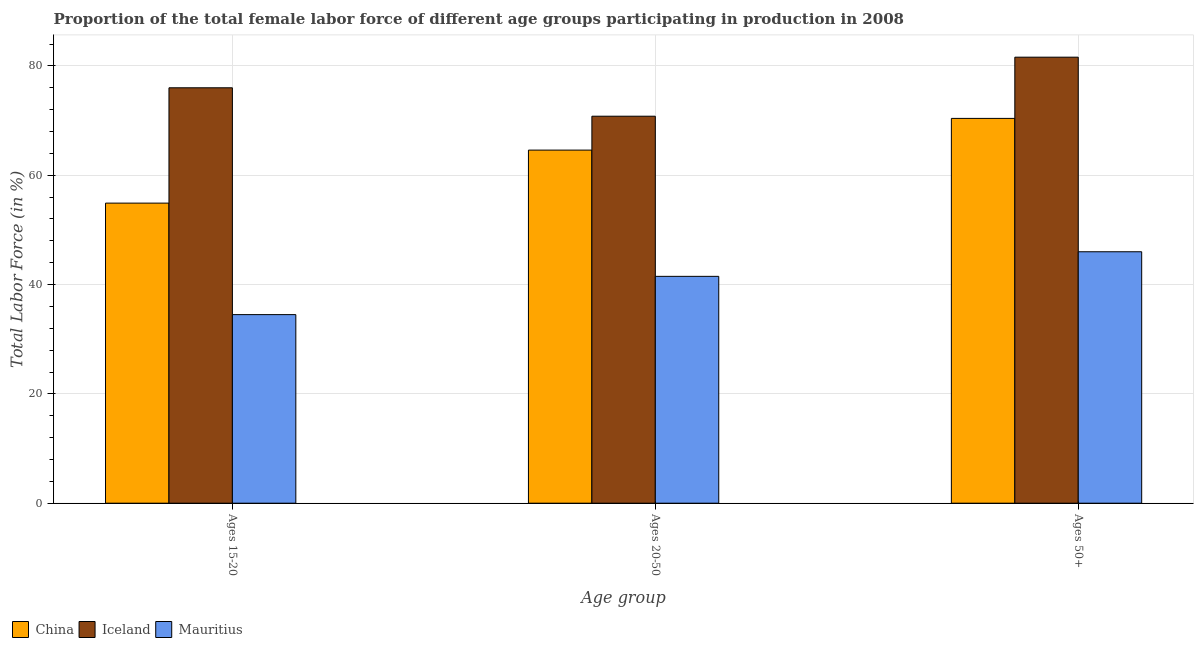How many different coloured bars are there?
Provide a succinct answer. 3. How many groups of bars are there?
Your answer should be compact. 3. Are the number of bars per tick equal to the number of legend labels?
Keep it short and to the point. Yes. Are the number of bars on each tick of the X-axis equal?
Give a very brief answer. Yes. How many bars are there on the 1st tick from the left?
Your response must be concise. 3. How many bars are there on the 3rd tick from the right?
Provide a short and direct response. 3. What is the label of the 1st group of bars from the left?
Your answer should be very brief. Ages 15-20. What is the percentage of female labor force within the age group 20-50 in Mauritius?
Make the answer very short. 41.5. Across all countries, what is the maximum percentage of female labor force within the age group 20-50?
Give a very brief answer. 70.8. Across all countries, what is the minimum percentage of female labor force within the age group 20-50?
Your answer should be compact. 41.5. In which country was the percentage of female labor force within the age group 20-50 minimum?
Your response must be concise. Mauritius. What is the total percentage of female labor force within the age group 20-50 in the graph?
Give a very brief answer. 176.9. What is the difference between the percentage of female labor force within the age group 15-20 in China and that in Iceland?
Make the answer very short. -21.1. What is the difference between the percentage of female labor force within the age group 20-50 in Iceland and the percentage of female labor force within the age group 15-20 in China?
Your answer should be compact. 15.9. What is the average percentage of female labor force above age 50 per country?
Provide a short and direct response. 66. What is the difference between the percentage of female labor force within the age group 15-20 and percentage of female labor force above age 50 in Iceland?
Make the answer very short. -5.6. What is the ratio of the percentage of female labor force within the age group 20-50 in China to that in Iceland?
Provide a succinct answer. 0.91. What is the difference between the highest and the second highest percentage of female labor force within the age group 15-20?
Your response must be concise. 21.1. What is the difference between the highest and the lowest percentage of female labor force above age 50?
Offer a terse response. 35.6. In how many countries, is the percentage of female labor force within the age group 20-50 greater than the average percentage of female labor force within the age group 20-50 taken over all countries?
Provide a succinct answer. 2. What does the 1st bar from the right in Ages 50+ represents?
Give a very brief answer. Mauritius. Are all the bars in the graph horizontal?
Offer a terse response. No. How many countries are there in the graph?
Your answer should be very brief. 3. Are the values on the major ticks of Y-axis written in scientific E-notation?
Provide a short and direct response. No. Does the graph contain any zero values?
Provide a succinct answer. No. Does the graph contain grids?
Your answer should be very brief. Yes. Where does the legend appear in the graph?
Offer a terse response. Bottom left. How are the legend labels stacked?
Your answer should be compact. Horizontal. What is the title of the graph?
Make the answer very short. Proportion of the total female labor force of different age groups participating in production in 2008. Does "American Samoa" appear as one of the legend labels in the graph?
Your answer should be very brief. No. What is the label or title of the X-axis?
Keep it short and to the point. Age group. What is the Total Labor Force (in %) of China in Ages 15-20?
Your response must be concise. 54.9. What is the Total Labor Force (in %) in Iceland in Ages 15-20?
Keep it short and to the point. 76. What is the Total Labor Force (in %) in Mauritius in Ages 15-20?
Keep it short and to the point. 34.5. What is the Total Labor Force (in %) of China in Ages 20-50?
Keep it short and to the point. 64.6. What is the Total Labor Force (in %) of Iceland in Ages 20-50?
Offer a very short reply. 70.8. What is the Total Labor Force (in %) of Mauritius in Ages 20-50?
Offer a terse response. 41.5. What is the Total Labor Force (in %) in China in Ages 50+?
Keep it short and to the point. 70.4. What is the Total Labor Force (in %) in Iceland in Ages 50+?
Your answer should be compact. 81.6. What is the Total Labor Force (in %) of Mauritius in Ages 50+?
Your answer should be very brief. 46. Across all Age group, what is the maximum Total Labor Force (in %) of China?
Your response must be concise. 70.4. Across all Age group, what is the maximum Total Labor Force (in %) of Iceland?
Provide a short and direct response. 81.6. Across all Age group, what is the maximum Total Labor Force (in %) in Mauritius?
Your answer should be compact. 46. Across all Age group, what is the minimum Total Labor Force (in %) of China?
Your answer should be very brief. 54.9. Across all Age group, what is the minimum Total Labor Force (in %) of Iceland?
Make the answer very short. 70.8. Across all Age group, what is the minimum Total Labor Force (in %) of Mauritius?
Your answer should be compact. 34.5. What is the total Total Labor Force (in %) in China in the graph?
Offer a terse response. 189.9. What is the total Total Labor Force (in %) of Iceland in the graph?
Ensure brevity in your answer.  228.4. What is the total Total Labor Force (in %) in Mauritius in the graph?
Offer a very short reply. 122. What is the difference between the Total Labor Force (in %) of Mauritius in Ages 15-20 and that in Ages 20-50?
Keep it short and to the point. -7. What is the difference between the Total Labor Force (in %) in China in Ages 15-20 and that in Ages 50+?
Offer a very short reply. -15.5. What is the difference between the Total Labor Force (in %) in Mauritius in Ages 20-50 and that in Ages 50+?
Your response must be concise. -4.5. What is the difference between the Total Labor Force (in %) of China in Ages 15-20 and the Total Labor Force (in %) of Iceland in Ages 20-50?
Your response must be concise. -15.9. What is the difference between the Total Labor Force (in %) of Iceland in Ages 15-20 and the Total Labor Force (in %) of Mauritius in Ages 20-50?
Keep it short and to the point. 34.5. What is the difference between the Total Labor Force (in %) of China in Ages 15-20 and the Total Labor Force (in %) of Iceland in Ages 50+?
Give a very brief answer. -26.7. What is the difference between the Total Labor Force (in %) of China in Ages 15-20 and the Total Labor Force (in %) of Mauritius in Ages 50+?
Make the answer very short. 8.9. What is the difference between the Total Labor Force (in %) in Iceland in Ages 20-50 and the Total Labor Force (in %) in Mauritius in Ages 50+?
Your answer should be compact. 24.8. What is the average Total Labor Force (in %) in China per Age group?
Your response must be concise. 63.3. What is the average Total Labor Force (in %) of Iceland per Age group?
Make the answer very short. 76.13. What is the average Total Labor Force (in %) of Mauritius per Age group?
Make the answer very short. 40.67. What is the difference between the Total Labor Force (in %) in China and Total Labor Force (in %) in Iceland in Ages 15-20?
Your answer should be compact. -21.1. What is the difference between the Total Labor Force (in %) of China and Total Labor Force (in %) of Mauritius in Ages 15-20?
Give a very brief answer. 20.4. What is the difference between the Total Labor Force (in %) in Iceland and Total Labor Force (in %) in Mauritius in Ages 15-20?
Ensure brevity in your answer.  41.5. What is the difference between the Total Labor Force (in %) of China and Total Labor Force (in %) of Iceland in Ages 20-50?
Ensure brevity in your answer.  -6.2. What is the difference between the Total Labor Force (in %) of China and Total Labor Force (in %) of Mauritius in Ages 20-50?
Offer a very short reply. 23.1. What is the difference between the Total Labor Force (in %) of Iceland and Total Labor Force (in %) of Mauritius in Ages 20-50?
Your response must be concise. 29.3. What is the difference between the Total Labor Force (in %) of China and Total Labor Force (in %) of Mauritius in Ages 50+?
Your response must be concise. 24.4. What is the difference between the Total Labor Force (in %) in Iceland and Total Labor Force (in %) in Mauritius in Ages 50+?
Provide a short and direct response. 35.6. What is the ratio of the Total Labor Force (in %) in China in Ages 15-20 to that in Ages 20-50?
Keep it short and to the point. 0.85. What is the ratio of the Total Labor Force (in %) of Iceland in Ages 15-20 to that in Ages 20-50?
Provide a short and direct response. 1.07. What is the ratio of the Total Labor Force (in %) of Mauritius in Ages 15-20 to that in Ages 20-50?
Provide a short and direct response. 0.83. What is the ratio of the Total Labor Force (in %) of China in Ages 15-20 to that in Ages 50+?
Keep it short and to the point. 0.78. What is the ratio of the Total Labor Force (in %) of Iceland in Ages 15-20 to that in Ages 50+?
Ensure brevity in your answer.  0.93. What is the ratio of the Total Labor Force (in %) in Mauritius in Ages 15-20 to that in Ages 50+?
Offer a very short reply. 0.75. What is the ratio of the Total Labor Force (in %) in China in Ages 20-50 to that in Ages 50+?
Provide a succinct answer. 0.92. What is the ratio of the Total Labor Force (in %) of Iceland in Ages 20-50 to that in Ages 50+?
Your answer should be very brief. 0.87. What is the ratio of the Total Labor Force (in %) in Mauritius in Ages 20-50 to that in Ages 50+?
Ensure brevity in your answer.  0.9. What is the difference between the highest and the second highest Total Labor Force (in %) of China?
Your answer should be compact. 5.8. What is the difference between the highest and the second highest Total Labor Force (in %) of Iceland?
Give a very brief answer. 5.6. What is the difference between the highest and the lowest Total Labor Force (in %) of China?
Provide a short and direct response. 15.5. What is the difference between the highest and the lowest Total Labor Force (in %) in Iceland?
Offer a terse response. 10.8. What is the difference between the highest and the lowest Total Labor Force (in %) of Mauritius?
Provide a succinct answer. 11.5. 